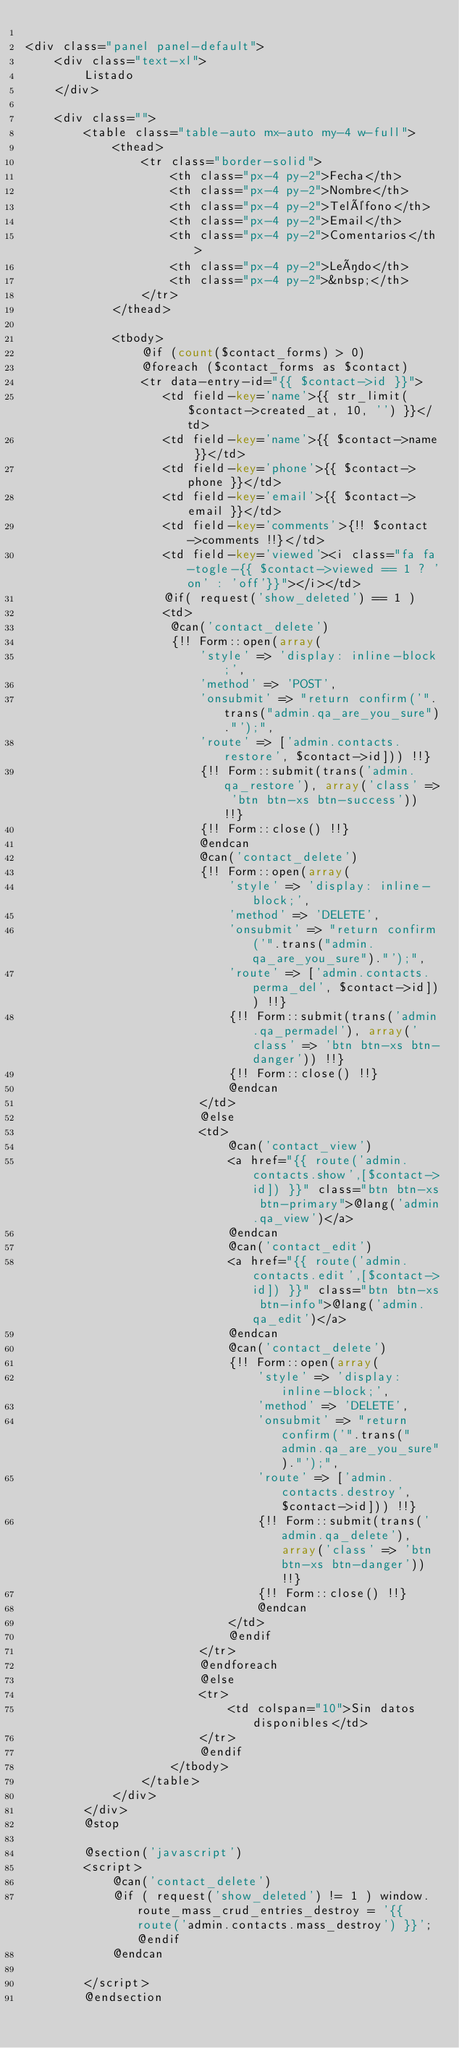Convert code to text. <code><loc_0><loc_0><loc_500><loc_500><_PHP_>
<div class="panel panel-default">
    <div class="text-xl">
        Listado
    </div>

    <div class="">
        <table class="table-auto mx-auto my-4 w-full">
            <thead>
                <tr class="border-solid">
                    <th class="px-4 py-2">Fecha</th>
                    <th class="px-4 py-2">Nombre</th>
                    <th class="px-4 py-2">Teléfono</th>
                    <th class="px-4 py-2">Email</th>
                    <th class="px-4 py-2">Comentarios</th>
                    <th class="px-4 py-2">Leído</th>
                    <th class="px-4 py-2">&nbsp;</th>
                </tr>
            </thead>

            <tbody>
                @if (count($contact_forms) > 0)
                @foreach ($contact_forms as $contact)
                <tr data-entry-id="{{ $contact->id }}">
                   <td field-key='name'>{{ str_limit($contact->created_at, 10, '') }}</td>
                   <td field-key='name'>{{ $contact->name }}</td>
                   <td field-key='phone'>{{ $contact->phone }}</td>
                   <td field-key='email'>{{ $contact->email }}</td>
                   <td field-key='comments'>{!! $contact->comments !!}</td>
                   <td field-key='viewed'><i class="fa fa-togle-{{ $contact->viewed == 1 ? 'on' : 'off'}}"></i></td>
                   @if( request('show_deleted') == 1 )
                   <td>
                    @can('contact_delete')
                    {!! Form::open(array(
                        'style' => 'display: inline-block;',
                        'method' => 'POST',
                        'onsubmit' => "return confirm('".trans("admin.qa_are_you_sure")."');",
                        'route' => ['admin.contacts.restore', $contact->id])) !!}
                        {!! Form::submit(trans('admin.qa_restore'), array('class' => 'btn btn-xs btn-success')) !!}
                        {!! Form::close() !!}
                        @endcan
                        @can('contact_delete')
                        {!! Form::open(array(
                            'style' => 'display: inline-block;',
                            'method' => 'DELETE',
                            'onsubmit' => "return confirm('".trans("admin.qa_are_you_sure")."');",
                            'route' => ['admin.contacts.perma_del', $contact->id])) !!}
                            {!! Form::submit(trans('admin.qa_permadel'), array('class' => 'btn btn-xs btn-danger')) !!}
                            {!! Form::close() !!}
                            @endcan
                        </td>
                        @else
                        <td>
                            @can('contact_view')
                            <a href="{{ route('admin.contacts.show',[$contact->id]) }}" class="btn btn-xs btn-primary">@lang('admin.qa_view')</a>
                            @endcan
                            @can('contact_edit')
                            <a href="{{ route('admin.contacts.edit',[$contact->id]) }}" class="btn btn-xs btn-info">@lang('admin.qa_edit')</a>
                            @endcan
                            @can('contact_delete')
                            {!! Form::open(array(
                                'style' => 'display: inline-block;',
                                'method' => 'DELETE',
                                'onsubmit' => "return confirm('".trans("admin.qa_are_you_sure")."');",
                                'route' => ['admin.contacts.destroy', $contact->id])) !!}
                                {!! Form::submit(trans('admin.qa_delete'), array('class' => 'btn btn-xs btn-danger')) !!}
                                {!! Form::close() !!}
                                @endcan
                            </td>
                            @endif
                        </tr>
                        @endforeach
                        @else
                        <tr>
                            <td colspan="10">Sin datos disponibles</td>
                        </tr>
                        @endif
                    </tbody>
                </table>
            </div>
        </div>
        @stop

        @section('javascript') 
        <script>
            @can('contact_delete')
            @if ( request('show_deleted') != 1 ) window.route_mass_crud_entries_destroy = '{{ route('admin.contacts.mass_destroy') }}'; @endif
            @endcan

        </script>
        @endsection</code> 